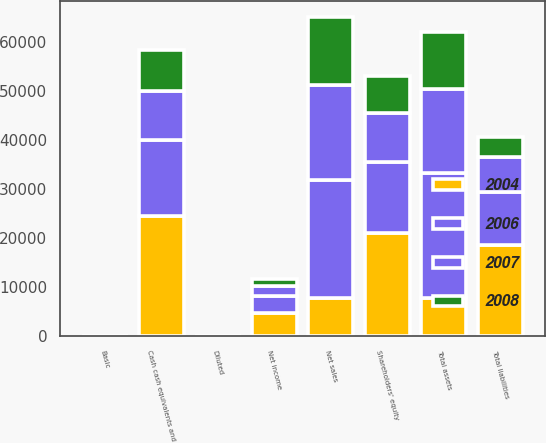Convert chart. <chart><loc_0><loc_0><loc_500><loc_500><stacked_bar_chart><ecel><fcel>Net sales<fcel>Net income<fcel>Basic<fcel>Diluted<fcel>Cash cash equivalents and<fcel>Total assets<fcel>Total liabilities<fcel>Shareholders' equity<nl><fcel>2004<fcel>7844.5<fcel>4834<fcel>5.48<fcel>5.36<fcel>24490<fcel>7844.5<fcel>18542<fcel>21030<nl><fcel>2006<fcel>24006<fcel>3496<fcel>4.04<fcel>3.93<fcel>15386<fcel>25347<fcel>10815<fcel>14532<nl><fcel>2007<fcel>19315<fcel>1989<fcel>2.36<fcel>2.27<fcel>10110<fcel>17205<fcel>7221<fcel>9984<nl><fcel>2008<fcel>13931<fcel>1328<fcel>1.64<fcel>1.55<fcel>8261<fcel>11516<fcel>4088<fcel>7428<nl></chart> 